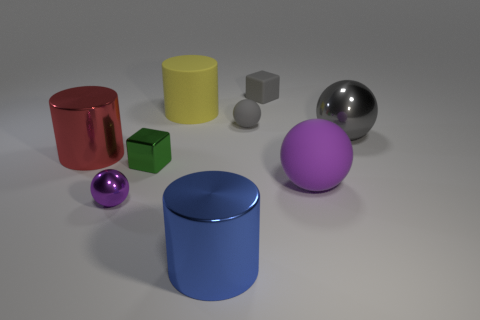There is a rubber block; is its size the same as the shiny ball that is to the right of the large blue metallic thing?
Your answer should be compact. No. The rubber object that is in front of the large metallic sphere has what shape?
Ensure brevity in your answer.  Sphere. Are there any large cylinders that are to the left of the matte sphere in front of the metallic ball behind the purple shiny sphere?
Keep it short and to the point. Yes. What is the material of the other small thing that is the same shape as the small green metal object?
Ensure brevity in your answer.  Rubber. How many cylinders are green metallic things or small gray rubber things?
Provide a succinct answer. 0. Is the size of the object right of the large purple matte thing the same as the blue cylinder that is in front of the red shiny cylinder?
Keep it short and to the point. Yes. What material is the small cube behind the cylinder that is behind the big gray metallic ball?
Offer a very short reply. Rubber. Are there fewer large rubber balls to the left of the yellow object than tiny brown cubes?
Your answer should be very brief. No. The tiny green object that is the same material as the tiny purple sphere is what shape?
Your response must be concise. Cube. How many other objects are there of the same shape as the large yellow rubber object?
Offer a terse response. 2. 